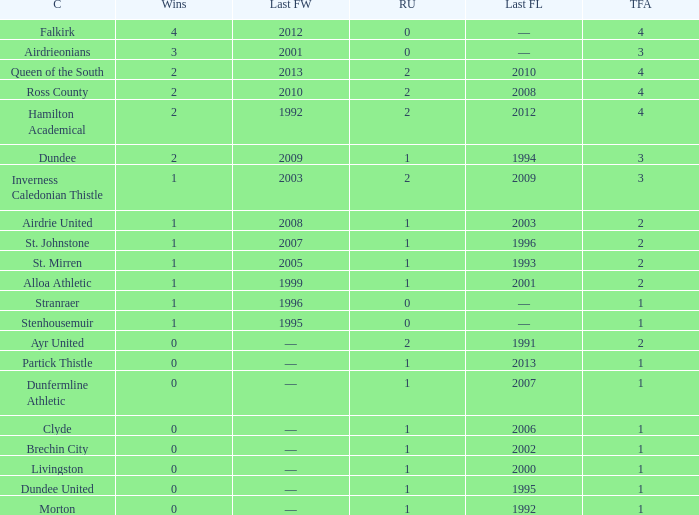What club has over 1 runners-up and last won the final in 2010? Ross County. 